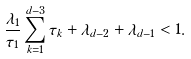<formula> <loc_0><loc_0><loc_500><loc_500>\frac { \lambda _ { 1 } } { \tau _ { 1 } } \sum _ { k = 1 } ^ { d - 3 } \tau _ { k } + \lambda _ { d - 2 } + \lambda _ { d - 1 } < 1 .</formula> 